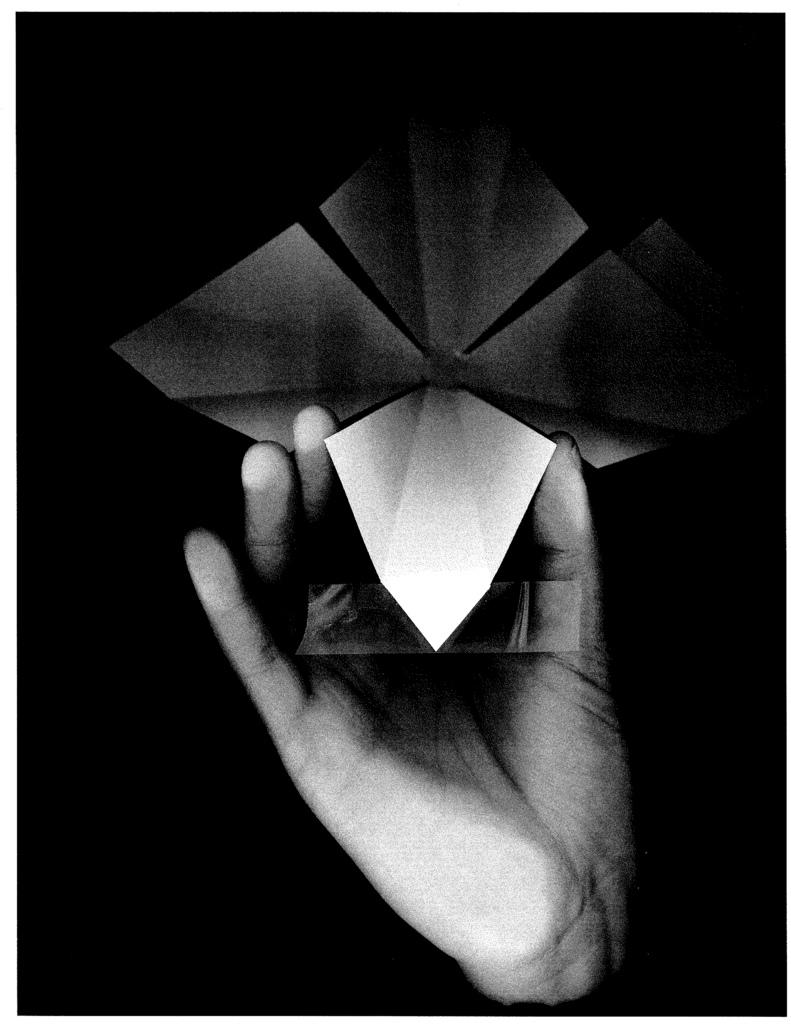What is being held by the person's hand in the image? There is no specific information about the object being held, only that a person's hand is holding something. Can you describe the position of the hand in the image? The position of the hand cannot be determined from the provided facts. Is there any indication of the person's identity or appearance in the image? No, the only information given is that a person's hand is holding an object. How many visitors are present in the image? There is no information about visitors in the image; only a person's hand holding an object is mentioned. 